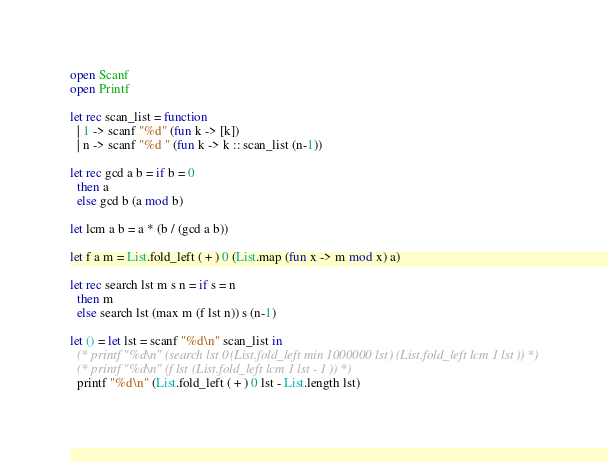<code> <loc_0><loc_0><loc_500><loc_500><_OCaml_>open Scanf
open Printf

let rec scan_list = function
  | 1 -> scanf "%d" (fun k -> [k])
  | n -> scanf "%d " (fun k -> k :: scan_list (n-1))

let rec gcd a b = if b = 0
  then a
  else gcd b (a mod b)

let lcm a b = a * (b / (gcd a b))

let f a m = List.fold_left ( + ) 0 (List.map (fun x -> m mod x) a)

let rec search lst m s n = if s = n
  then m
  else search lst (max m (f lst n)) s (n-1)

let () = let lst = scanf "%d\n" scan_list in
  (* printf "%d\n" (search lst 0 (List.fold_left min 1000000 lst) (List.fold_left lcm 1 lst)) *)
  (* printf "%d\n" (f lst (List.fold_left lcm 1 lst - 1)) *)
  printf "%d\n" (List.fold_left ( + ) 0 lst - List.length lst)</code> 